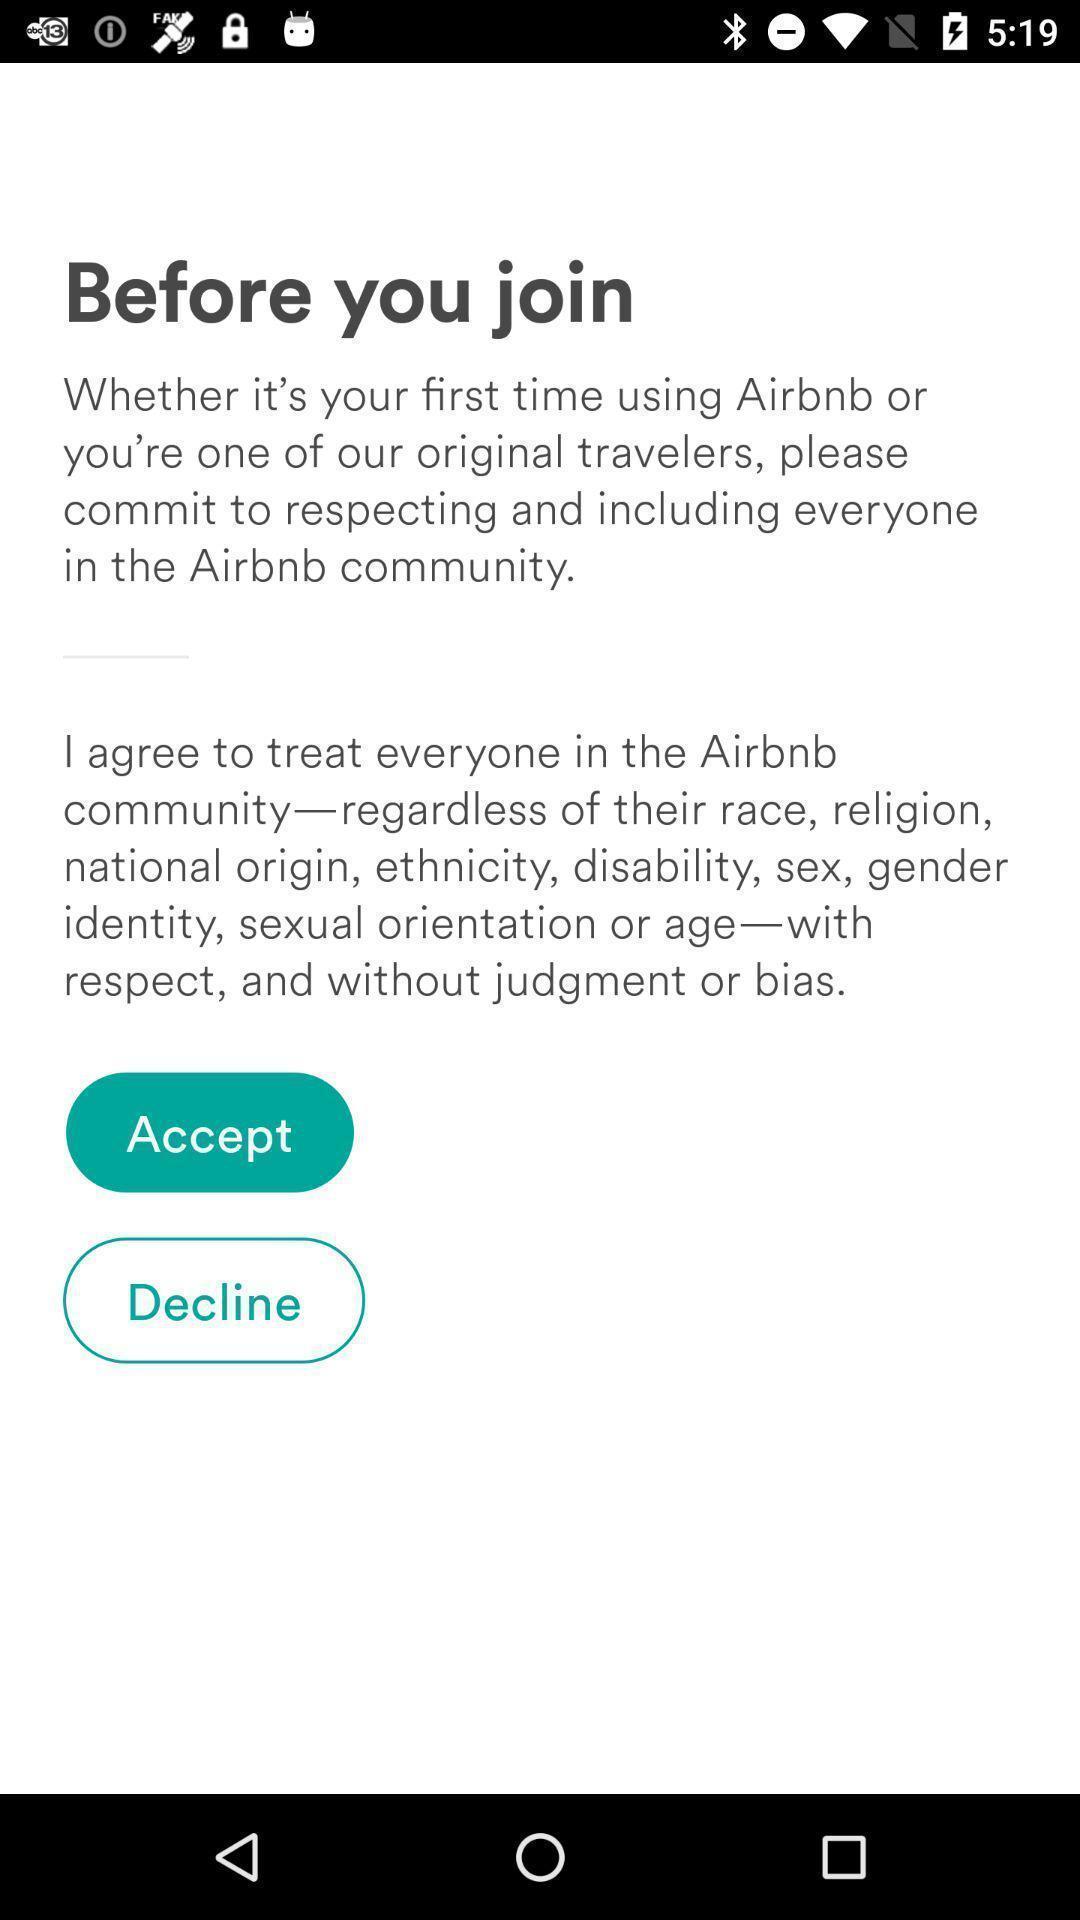Provide a description of this screenshot. Page displaying two options whether to accept or decline. 